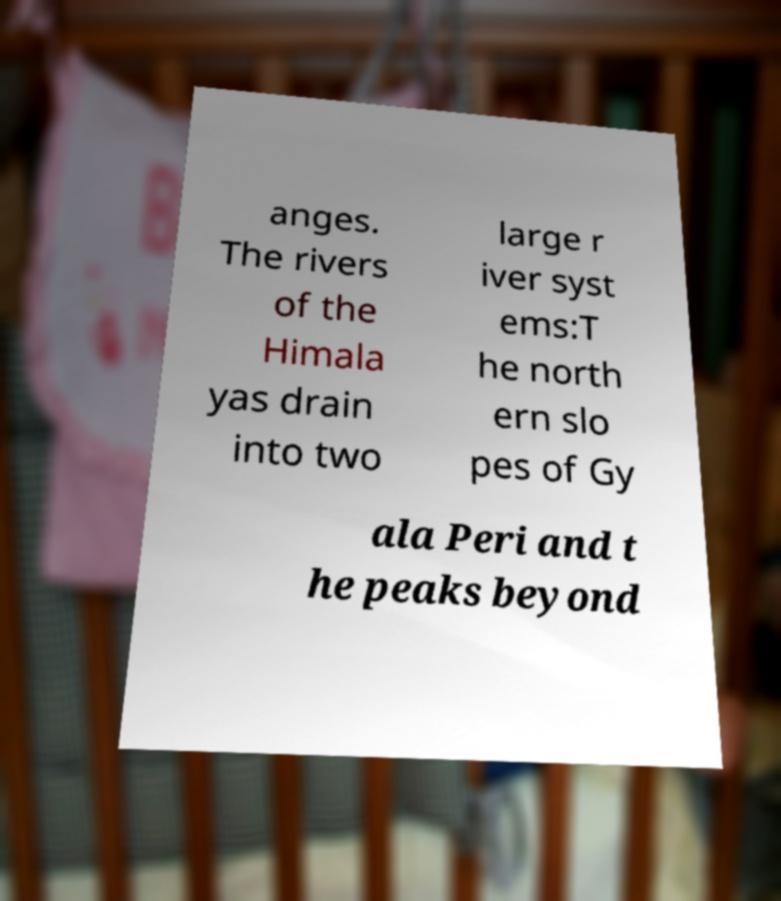Please read and relay the text visible in this image. What does it say? anges. The rivers of the Himala yas drain into two large r iver syst ems:T he north ern slo pes of Gy ala Peri and t he peaks beyond 